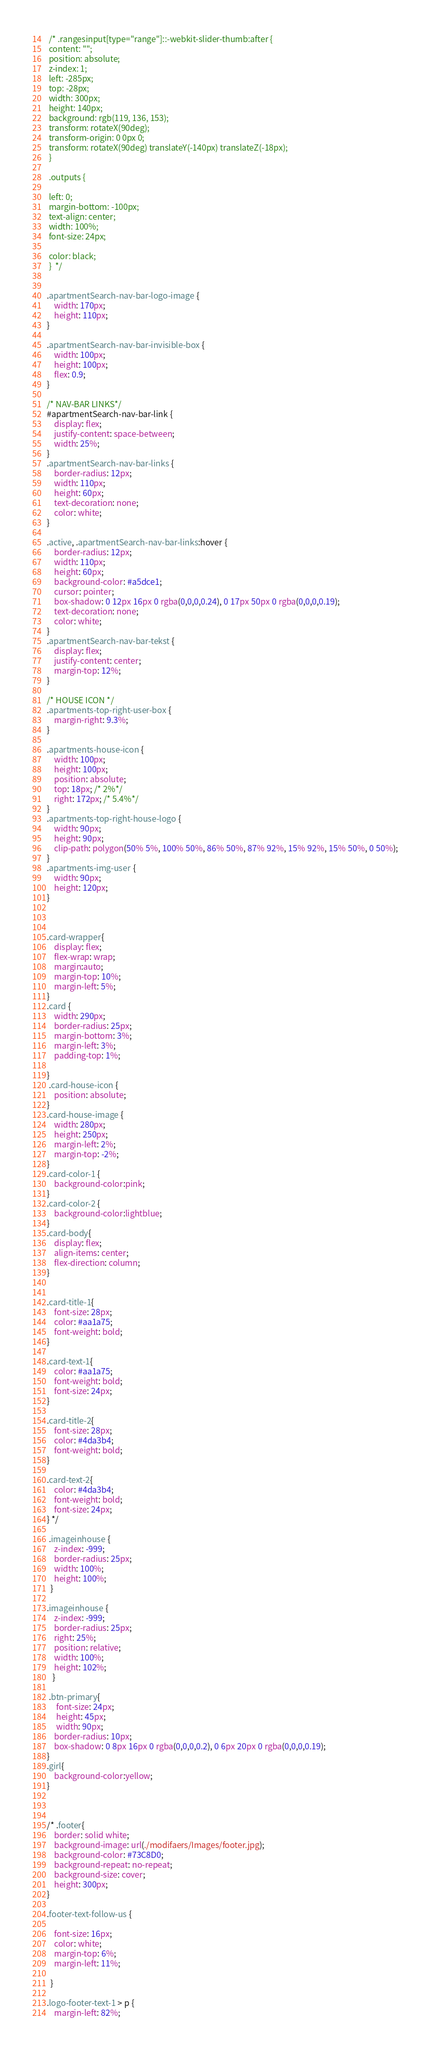<code> <loc_0><loc_0><loc_500><loc_500><_CSS_> /* .rangesinput[type="range"]::-webkit-slider-thumb:after {
 content: "";
 position: absolute;
 z-index: 1;
 left: -285px;
 top: -28px;
 width: 300px;
 height: 140px;
 background: rgb(119, 136, 153);
 transform: rotateX(90deg);
 transform-origin: 0 0px 0;
 transform: rotateX(90deg) translateY(-140px) translateZ(-18px);
 }
 
 .outputs {
 
 left: 0;
 margin-bottom: -100px;
 text-align: center;
 width: 100%;
 font-size: 24px;
 
 color: black;
 }  */


.apartmentSearch-nav-bar-logo-image {
    width: 170px;
    height: 110px;
}

.apartmentSearch-nav-bar-invisible-box {
    width: 100px;
    height: 100px;
    flex: 0.9;
}

/* NAV-BAR LINKS*/
#apartmentSearch-nav-bar-link {
    display: flex;
    justify-content: space-between;
    width: 25%;
}
.apartmentSearch-nav-bar-links {
    border-radius: 12px;
    width: 110px;
    height: 60px;
    text-decoration: none;
    color: white;
}

.active, .apartmentSearch-nav-bar-links:hover {
    border-radius: 12px;
    width: 110px;
    height: 60px;
    background-color: #a5dce1;
    cursor: pointer;
    box-shadow: 0 12px 16px 0 rgba(0,0,0,0.24), 0 17px 50px 0 rgba(0,0,0,0.19);
    text-decoration: none;
    color: white;
}
.apartmentSearch-nav-bar-tekst {
    display: flex;    
    justify-content: center;
    margin-top: 12%;
}

/* HOUSE ICON */
.apartments-top-right-user-box {
    margin-right: 9.3%;
}

.apartments-house-icon {
    width: 100px;
    height: 100px;
    position: absolute;
    top: 18px; /* 2%*/
    right: 172px; /* 5.4%*/
}
.apartments-top-right-house-logo {
    width: 90px;
    height: 90px;
    clip-path: polygon(50% 5%, 100% 50%, 86% 50%, 87% 92%, 15% 92%, 15% 50%, 0 50%);
}
.apartments-img-user {
    width: 90px;
    height: 120px;
}



.card-wrapper{
    display: flex;
    flex-wrap: wrap;
    margin:auto;
    margin-top: 10%;
    margin-left: 5%;
}
.card {
    width: 290px;
    border-radius: 25px;
    margin-bottom: 3%;
    margin-left: 3%;
    padding-top: 1%;
    
} 
 .card-house-icon {
    position: absolute;
}
.card-house-image {
    width: 280px;
    height: 250px;
    margin-left: 2%;
    margin-top: -2%;
}
.card-color-1 {
    background-color:pink;
}
.card-color-2 {
    background-color:lightblue;
}
.card-body{
    display: flex;
    align-items: center;
    flex-direction: column;
}


.card-title-1{
    font-size: 28px;
    color: #aa1a75;
    font-weight: bold;
}

.card-text-1{
    color: #aa1a75;
    font-weight: bold;
    font-size: 24px;
}

.card-title-2{
    font-size: 28px;
    color: #4da3b4;
    font-weight: bold;
}

.card-text-2{
    color: #4da3b4;
    font-weight: bold;
    font-size: 24px;
} */

 .imageinhouse {
    z-index: -999;
    border-radius: 25px;
    width: 100%;
    height: 100%;
  }

.imageinhouse {
    z-index: -999;
    border-radius: 25px;
    right: 25%;
    position: relative;
    width: 100%;
    height: 102%;
   } 

 .btn-primary{
     font-size: 24px;
     height: 45px;
     width: 90px;
    border-radius: 10px;
    box-shadow: 0 8px 16px 0 rgba(0,0,0,0.2), 0 6px 20px 0 rgba(0,0,0,0.19);
}
.girl{
    background-color:yellow;
}  



/* .footer{
    border: solid white;
    background-image: url(./modifaers/Images/footer.jpg);
    background-color: #73C8D0;
    background-repeat: no-repeat;
    background-size: cover;
    height: 300px;
}

.footer-text-follow-us {
    
    font-size: 16px;
    color: white;
    margin-top: 6%;
    margin-left: 11%;         
     
  }
  
.logo-footer-text-1 > p {    
    margin-left: 82%;</code> 